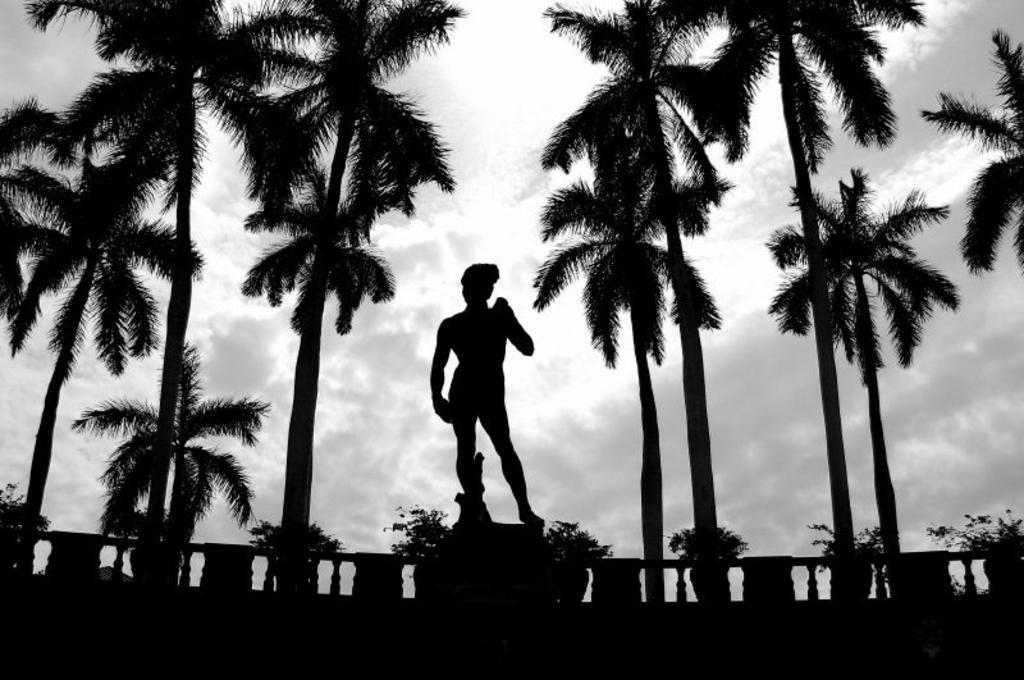In one or two sentences, can you explain what this image depicts? In the image we can see there is a statue of a person standing and behind there are lot of trees. The image is in black and white colour. 